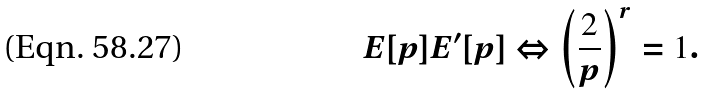<formula> <loc_0><loc_0><loc_500><loc_500>E [ p ] E ^ { \prime } [ p ] \Leftrightarrow \left ( \frac { 2 } { p } \right ) ^ { r } = 1 .</formula> 